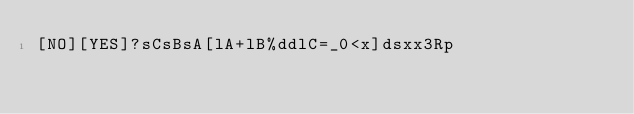<code> <loc_0><loc_0><loc_500><loc_500><_dc_>[NO][YES]?sCsBsA[lA+lB%ddlC=_0<x]dsxx3Rp</code> 